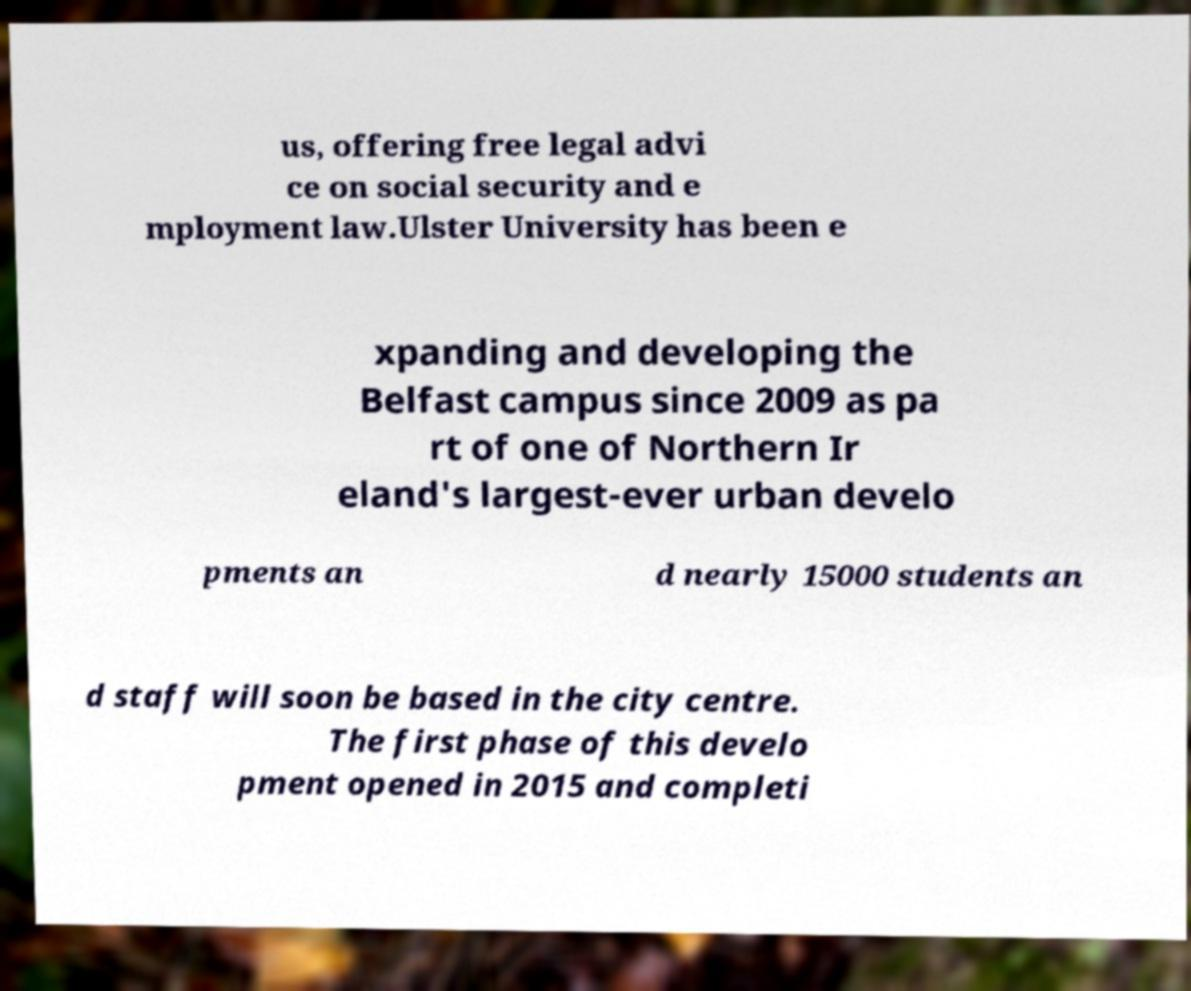Can you read and provide the text displayed in the image?This photo seems to have some interesting text. Can you extract and type it out for me? us, offering free legal advi ce on social security and e mployment law.Ulster University has been e xpanding and developing the Belfast campus since 2009 as pa rt of one of Northern Ir eland's largest-ever urban develo pments an d nearly 15000 students an d staff will soon be based in the city centre. The first phase of this develo pment opened in 2015 and completi 